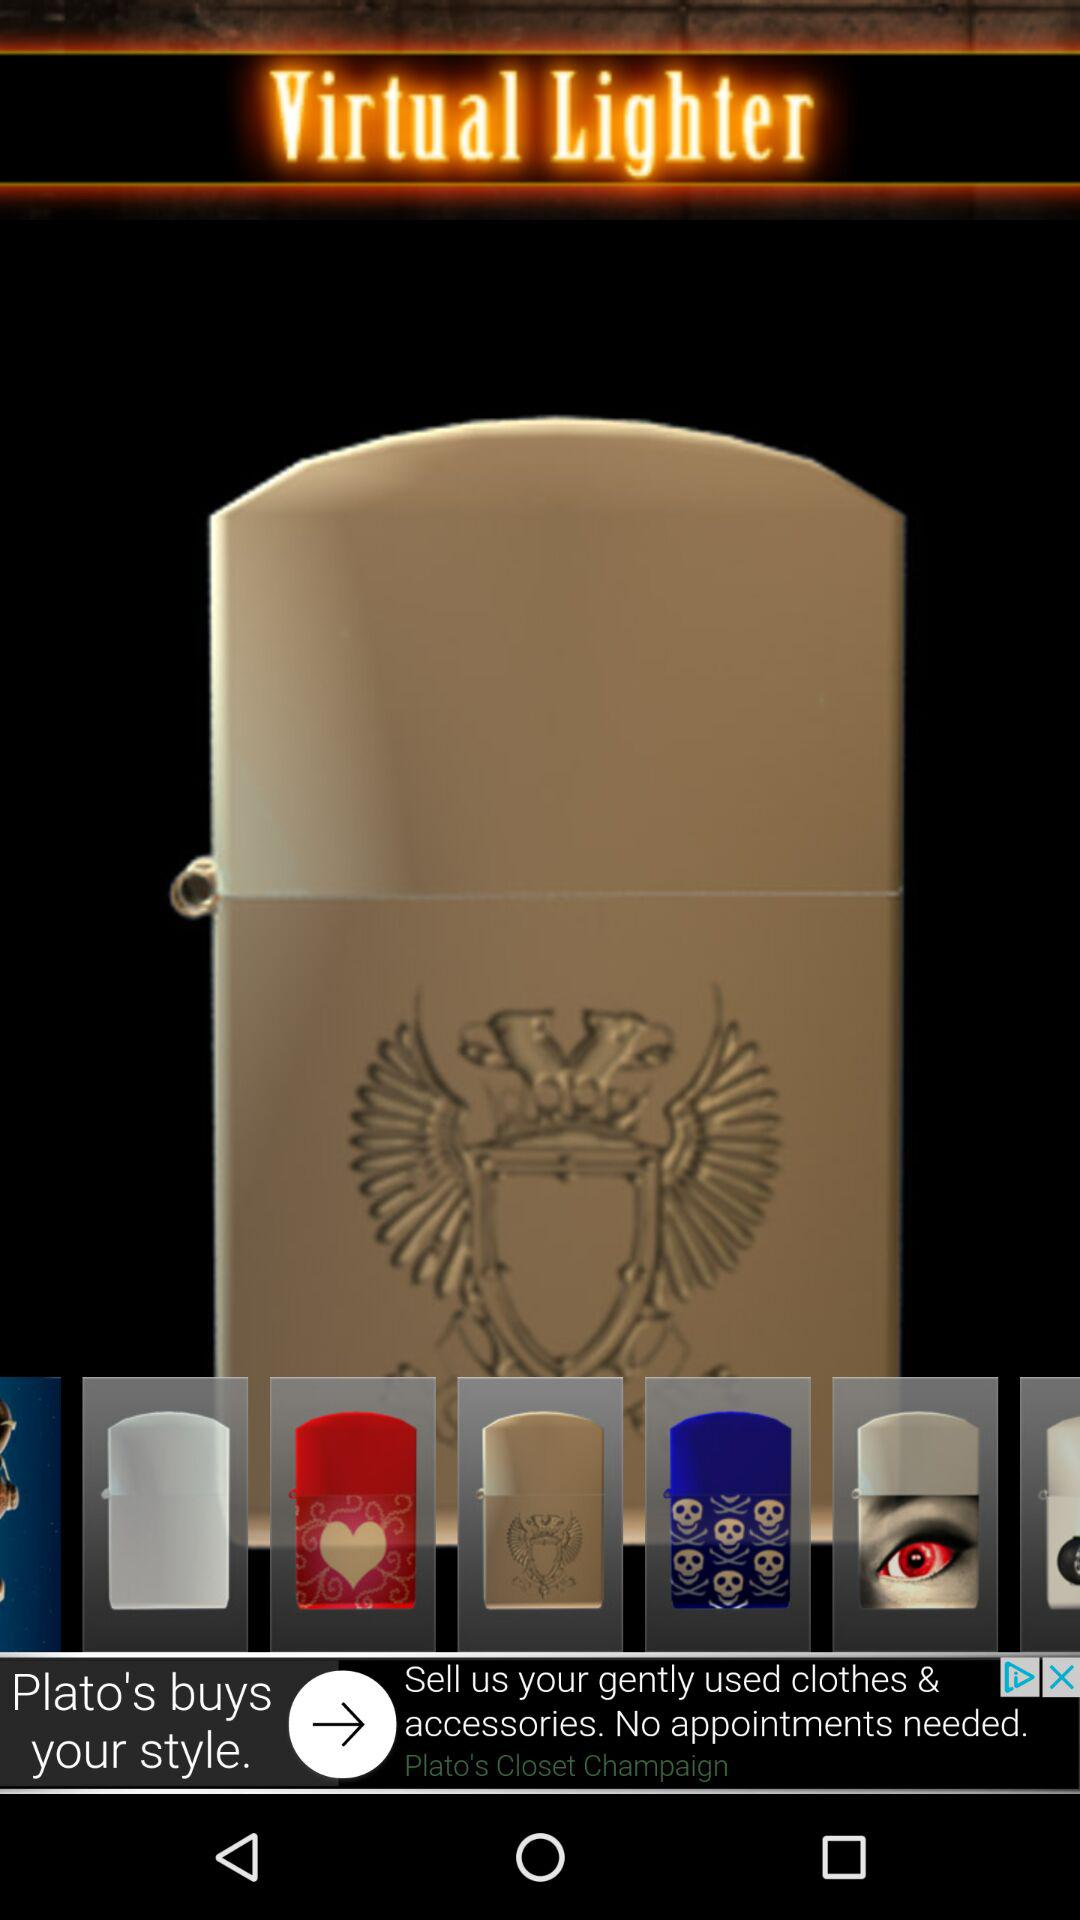What is the application name? The application name is "Virtual Lighter". 